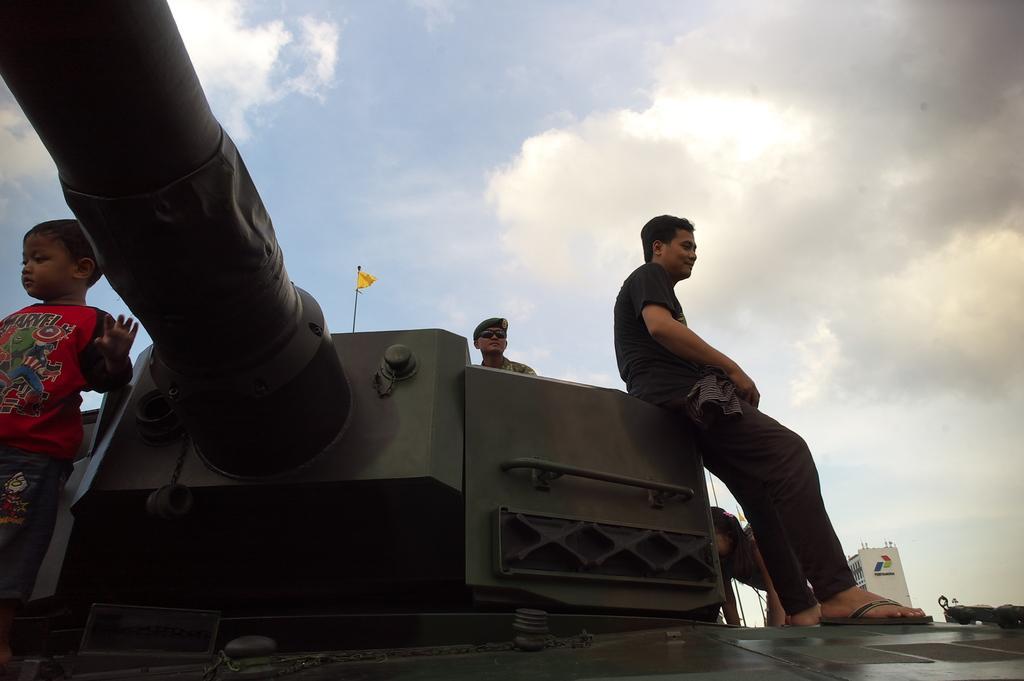How would you summarize this image in a sentence or two? In this image there is a military tank. A person is sitting on it. Left side there is a kid wearing a red shirt is standing on the military tank. Behind the tank there is a person wearing a cap and goggles. There is a flag attached to the pole. Right side there is a building. Beside there are few trees. Top of image there is sky with some clouds. 